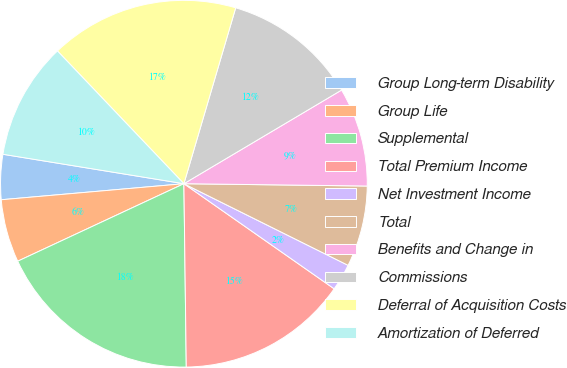Convert chart to OTSL. <chart><loc_0><loc_0><loc_500><loc_500><pie_chart><fcel>Group Long-term Disability<fcel>Group Life<fcel>Supplemental<fcel>Total Premium Income<fcel>Net Investment Income<fcel>Total<fcel>Benefits and Change in<fcel>Commissions<fcel>Deferral of Acquisition Costs<fcel>Amortization of Deferred<nl><fcel>3.96%<fcel>5.55%<fcel>18.26%<fcel>15.08%<fcel>2.37%<fcel>7.14%<fcel>8.73%<fcel>11.91%<fcel>16.67%<fcel>10.32%<nl></chart> 